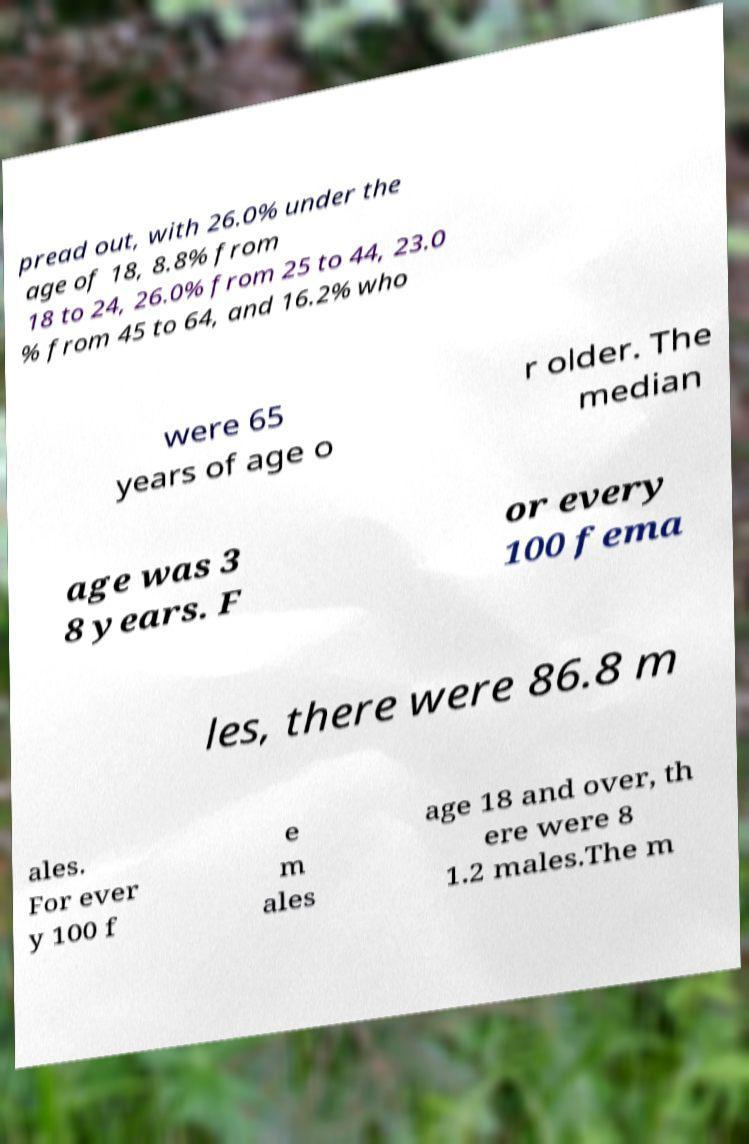Could you extract and type out the text from this image? pread out, with 26.0% under the age of 18, 8.8% from 18 to 24, 26.0% from 25 to 44, 23.0 % from 45 to 64, and 16.2% who were 65 years of age o r older. The median age was 3 8 years. F or every 100 fema les, there were 86.8 m ales. For ever y 100 f e m ales age 18 and over, th ere were 8 1.2 males.The m 